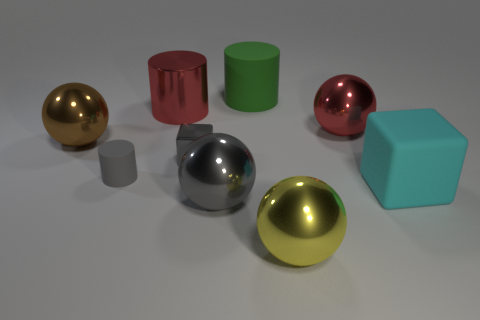Subtract all large yellow metal spheres. How many spheres are left? 3 Subtract all gray spheres. How many spheres are left? 3 Add 1 large cyan rubber cubes. How many objects exist? 10 Subtract all green balls. Subtract all red blocks. How many balls are left? 4 Subtract all cylinders. How many objects are left? 6 Add 1 brown spheres. How many brown spheres are left? 2 Add 8 cyan rubber cubes. How many cyan rubber cubes exist? 9 Subtract 1 cyan blocks. How many objects are left? 8 Subtract all brown spheres. Subtract all large green matte cylinders. How many objects are left? 7 